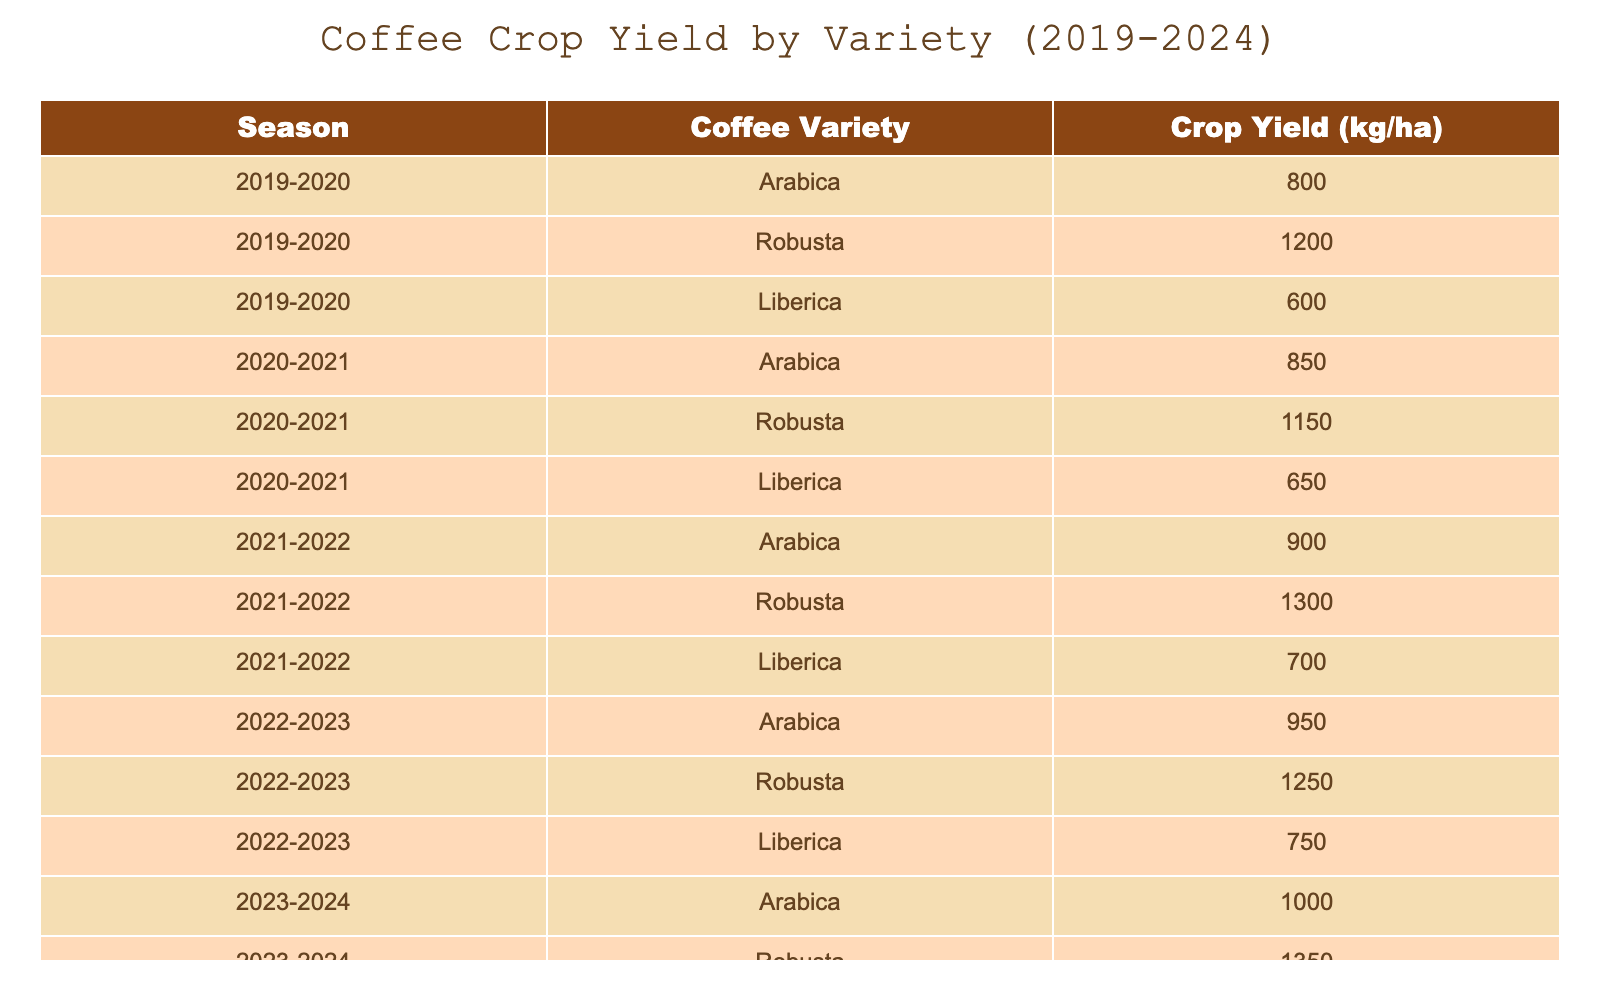What was the crop yield of Robusta coffee in the 2021-2022 season? From the table, I locate the row for the 2021-2022 season and find the value listed under Robusta, which is 1300 kg/ha.
Answer: 1300 kg/ha Which coffee variety had the lowest yield in the 2020-2021 season? In the 2020-2021 season, I compare the yields of Arabica (850 kg/ha), Robusta (1150 kg/ha), and Liberica (650 kg/ha). The lowest yield is from Liberica at 650 kg/ha.
Answer: Liberica What is the total crop yield of Arabica coffee across all seasons? The yields for Arabica are 800 (2019-2020), 850 (2020-2021), 900 (2021-2022), 950 (2022-2023), and 1000 (2023-2024). Adding these together gives: 800 + 850 + 900 + 950 + 1000 = 4500 kg/ha.
Answer: 4500 kg/ha Is it true that the yield of Liberica coffee increased every season? I examine the yields for Liberica: 600 (2019-2020), 650 (2020-2021), 700 (2021-2022), 750 (2022-2023), and 800 (2023-2024). Since each value is greater than the previous season, the statement is true.
Answer: Yes What was the average yield of Robusta coffee over the five seasons? The Robusta yields are 1200 (2019-2020), 1150 (2020-2021), 1300 (2021-2022), 1250 (2022-2023), and 1350 (2023-2024). Adding these values gives 1200 + 1150 + 1300 + 1250 + 1350 = 6250 kg/ha. Dividing by 5 for the average: 6250 / 5 = 1250 kg/ha.
Answer: 1250 kg/ha 